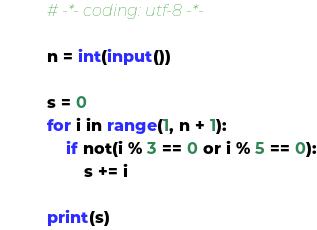<code> <loc_0><loc_0><loc_500><loc_500><_Python_># -*- coding: utf-8 -*-

n = int(input())

s = 0
for i in range(1, n + 1):
    if not(i % 3 == 0 or i % 5 == 0):
        s += i

print(s)
</code> 